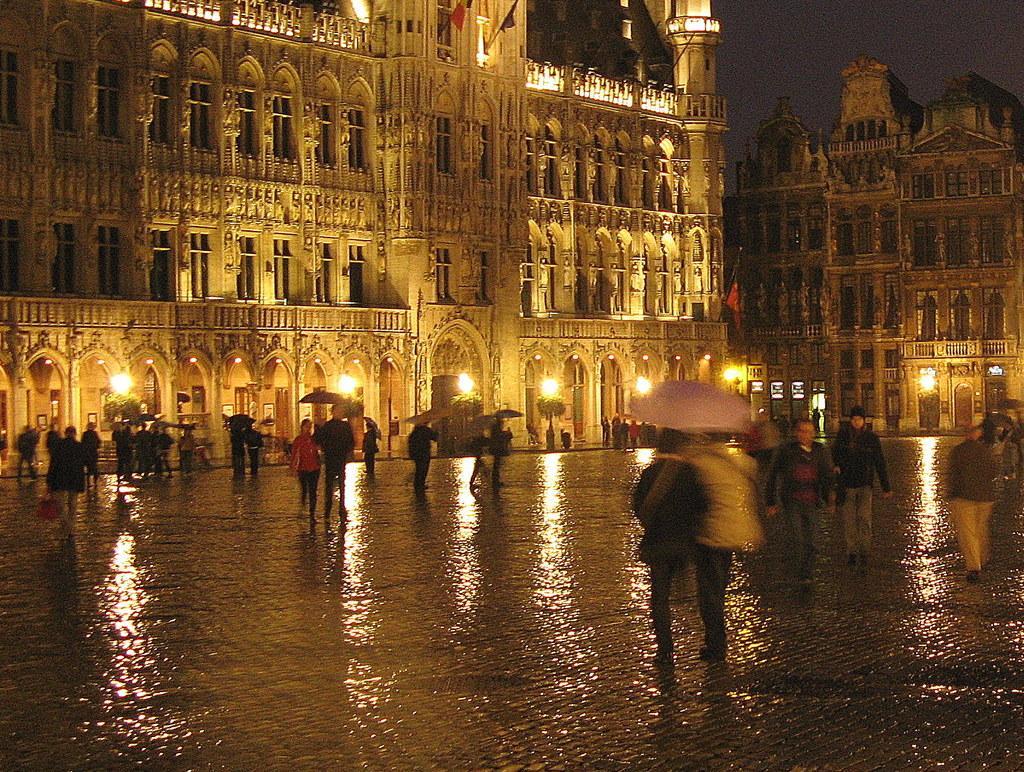In one or two sentences, can you explain what this image depicts? In this image we can see a group of people on the ground, some people are holding umbrellas in their hands. In the background, we can see buildings with windows, arches and dome lights, we can also see some plants and flags on poles. At the top of the image we can see the sky. 